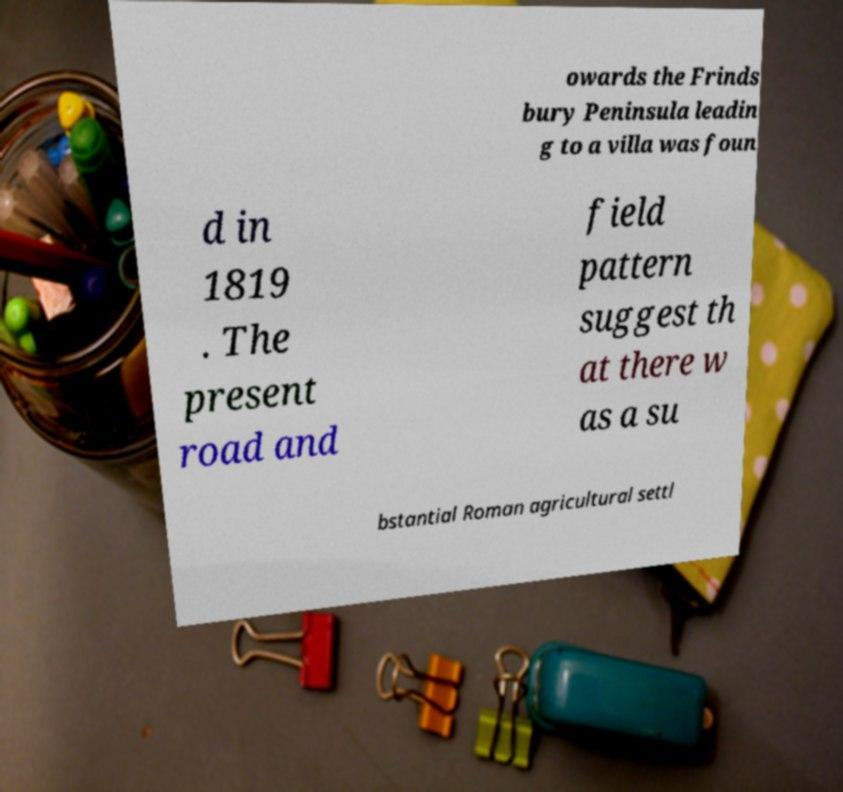Can you accurately transcribe the text from the provided image for me? owards the Frinds bury Peninsula leadin g to a villa was foun d in 1819 . The present road and field pattern suggest th at there w as a su bstantial Roman agricultural settl 